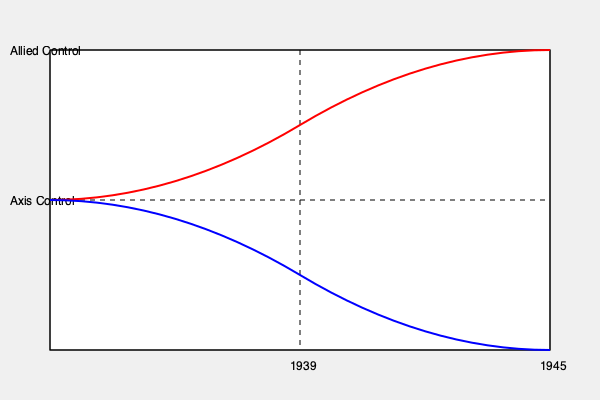Analyze the graph showing the spatial relationship between Allied and Axis territories in Europe from 1939 to 1945. What does the intersection point of the red and blue lines represent, and how does it relate to the turning point of World War II in Europe? 1. The graph represents the changing control of European territories by Allied (blue line) and Axis (red line) powers from 1939 to 1945.

2. The x-axis represents time from 1939 (start of WWII) to 1945 (end of WWII in Europe).

3. The y-axis represents the extent of territorial control, with the top half indicating Allied control and the bottom half indicating Axis control.

4. The red line (Axis control) starts high in 1939 and decreases over time, while the blue line (Allied control) starts low and increases over time.

5. The intersection point of the red and blue lines occurs approximately halfway through the timeline, around 1942-1943.

6. This intersection represents the point where Allied and Axis powers had roughly equal territorial control in Europe.

7. Historically, this corresponds to the turning point of World War II in Europe, which is generally considered to be around late 1942 to early 1943.

8. Key events during this period include:
   - The Battle of Stalingrad (August 1942 - February 1943)
   - The Second Battle of El Alamein (October - November 1942)
   - Operation Torch (November 1942)

9. After this point, the Allied powers began to gain more control, while Axis powers lost ground, as reflected by the diverging lines on the graph.
Answer: The intersection represents the turning point of WWII in Europe (1942-1943), when Allied and Axis powers had equal territorial control before Allied advances. 